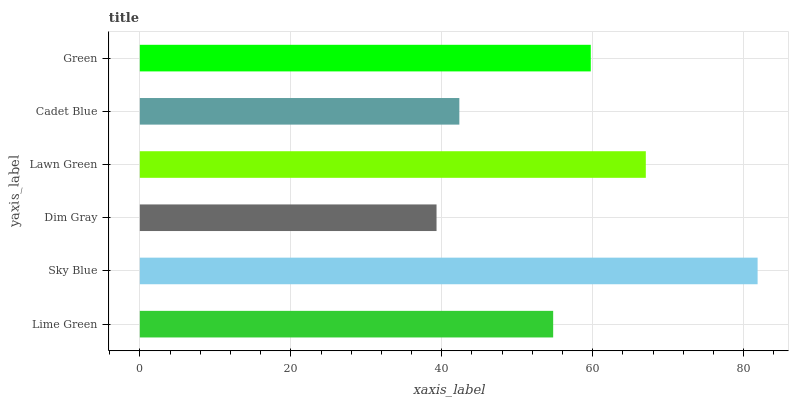Is Dim Gray the minimum?
Answer yes or no. Yes. Is Sky Blue the maximum?
Answer yes or no. Yes. Is Sky Blue the minimum?
Answer yes or no. No. Is Dim Gray the maximum?
Answer yes or no. No. Is Sky Blue greater than Dim Gray?
Answer yes or no. Yes. Is Dim Gray less than Sky Blue?
Answer yes or no. Yes. Is Dim Gray greater than Sky Blue?
Answer yes or no. No. Is Sky Blue less than Dim Gray?
Answer yes or no. No. Is Green the high median?
Answer yes or no. Yes. Is Lime Green the low median?
Answer yes or no. Yes. Is Lawn Green the high median?
Answer yes or no. No. Is Cadet Blue the low median?
Answer yes or no. No. 